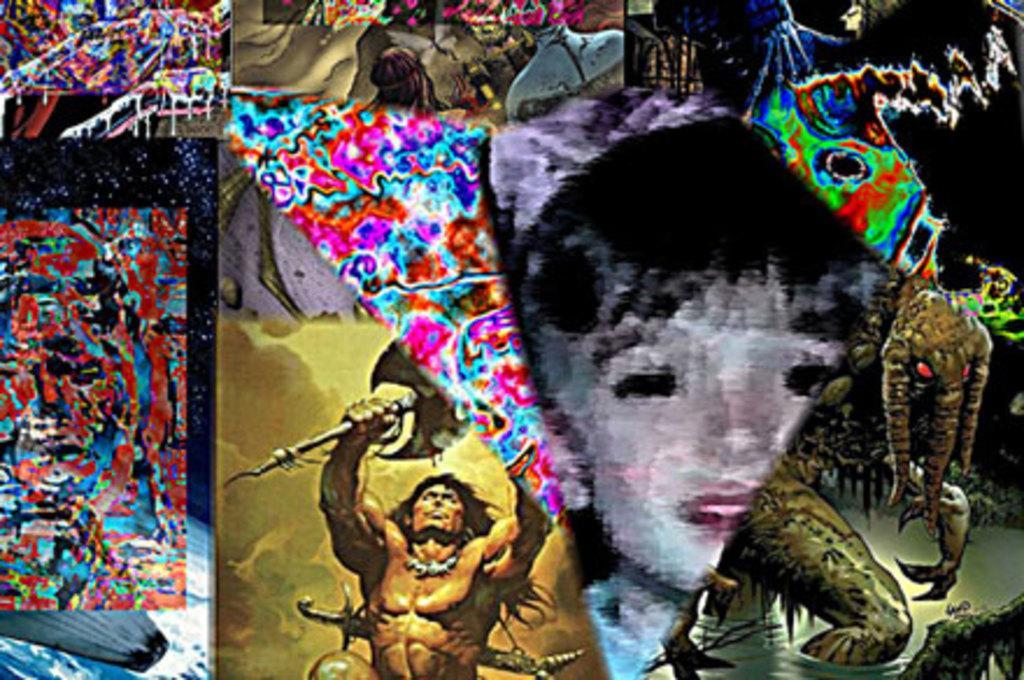In one or two sentences, can you explain what this image depicts? In this image I can see a painting ,on the painting I can see persons and animals visible. 